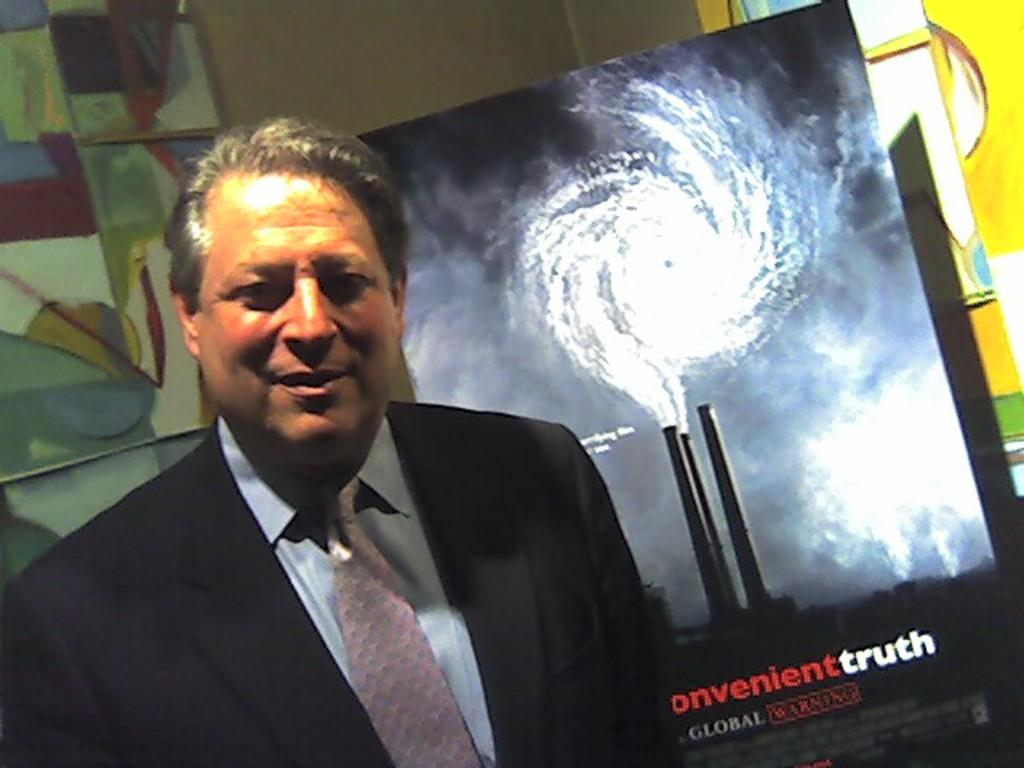Who is the main subject in the foreground of the image? There is a man in the foreground of the image. What can be seen in the background of the image? There is a poster and a wall visible in the background of the image. What type of quartz is used to create the poster in the image? There is no mention of quartz in the image, and the poster's material is not specified. How many steel beams are supporting the wall in the image? There is no mention of steel beams or any other structural elements supporting the wall in the image. 